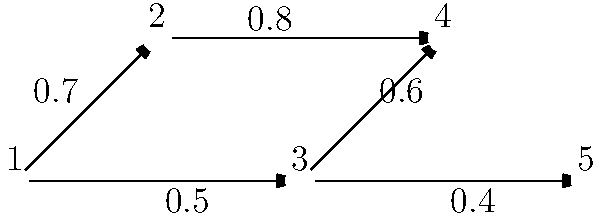Given the network diagram representing the spread of a computer virus, where nodes represent computers and edges represent connections with their associated infection probabilities, what is the probability that the virus will reach Node 5 if it originates at Node 1? Assume the virus can only spread in the direction of the arrows. To solve this problem, we need to follow these steps:

1. Identify all possible paths from Node 1 to Node 5.
2. Calculate the probability of infection for each path.
3. Combine the probabilities to get the overall probability of infection.

Step 1: Possible paths from Node 1 to Node 5
There is only one path: 1 → 2 → 5

Step 2: Calculate the probability for this path
The probability of infection along this path is the product of the probabilities along each edge:
$P(\text{1 → 2 → 5}) = 0.5 \times 0.4 = 0.2$

Step 3: Combine probabilities
Since there is only one path, the overall probability is simply the probability we calculated in step 2.

Therefore, the probability that the virus will reach Node 5 if it originates at Node 1 is 0.2 or 20%.

This approach uses the multiplication rule of probability for independent events (assuming each infection attempt is independent) and considers the directional nature of the virus spread as indicated by the arrows.
Answer: 0.2 